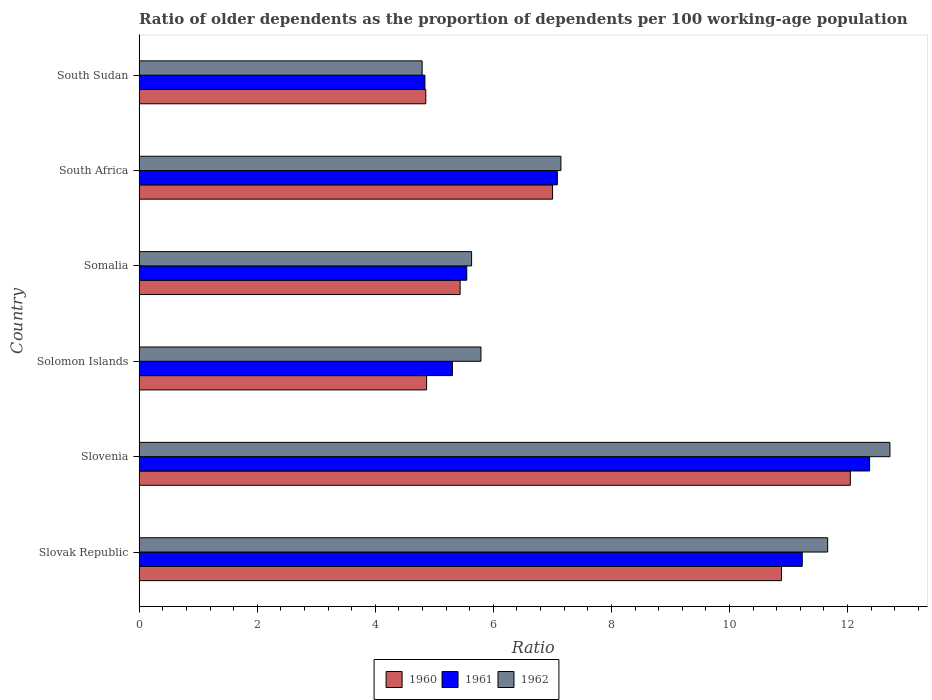How many different coloured bars are there?
Make the answer very short. 3. Are the number of bars per tick equal to the number of legend labels?
Offer a terse response. Yes. Are the number of bars on each tick of the Y-axis equal?
Make the answer very short. Yes. What is the label of the 4th group of bars from the top?
Keep it short and to the point. Solomon Islands. What is the age dependency ratio(old) in 1962 in Slovenia?
Your answer should be very brief. 12.72. Across all countries, what is the maximum age dependency ratio(old) in 1960?
Keep it short and to the point. 12.05. Across all countries, what is the minimum age dependency ratio(old) in 1961?
Your response must be concise. 4.84. In which country was the age dependency ratio(old) in 1961 maximum?
Give a very brief answer. Slovenia. In which country was the age dependency ratio(old) in 1962 minimum?
Ensure brevity in your answer.  South Sudan. What is the total age dependency ratio(old) in 1960 in the graph?
Make the answer very short. 45.1. What is the difference between the age dependency ratio(old) in 1961 in Slovenia and that in Somalia?
Make the answer very short. 6.82. What is the difference between the age dependency ratio(old) in 1960 in South Africa and the age dependency ratio(old) in 1962 in Somalia?
Your response must be concise. 1.37. What is the average age dependency ratio(old) in 1961 per country?
Provide a succinct answer. 7.73. What is the difference between the age dependency ratio(old) in 1962 and age dependency ratio(old) in 1961 in Solomon Islands?
Provide a succinct answer. 0.48. In how many countries, is the age dependency ratio(old) in 1960 greater than 10.4 ?
Offer a very short reply. 2. What is the ratio of the age dependency ratio(old) in 1962 in Slovenia to that in Somalia?
Make the answer very short. 2.26. Is the age dependency ratio(old) in 1962 in Slovenia less than that in Solomon Islands?
Provide a succinct answer. No. Is the difference between the age dependency ratio(old) in 1962 in Somalia and South Sudan greater than the difference between the age dependency ratio(old) in 1961 in Somalia and South Sudan?
Keep it short and to the point. Yes. What is the difference between the highest and the second highest age dependency ratio(old) in 1961?
Offer a terse response. 1.14. What is the difference between the highest and the lowest age dependency ratio(old) in 1962?
Your response must be concise. 7.92. What does the 3rd bar from the bottom in Slovak Republic represents?
Make the answer very short. 1962. Are all the bars in the graph horizontal?
Make the answer very short. Yes. What is the difference between two consecutive major ticks on the X-axis?
Make the answer very short. 2. Are the values on the major ticks of X-axis written in scientific E-notation?
Your answer should be very brief. No. How many legend labels are there?
Your answer should be compact. 3. What is the title of the graph?
Offer a very short reply. Ratio of older dependents as the proportion of dependents per 100 working-age population. What is the label or title of the X-axis?
Offer a very short reply. Ratio. What is the Ratio of 1960 in Slovak Republic?
Keep it short and to the point. 10.88. What is the Ratio of 1961 in Slovak Republic?
Keep it short and to the point. 11.23. What is the Ratio of 1962 in Slovak Republic?
Your answer should be very brief. 11.66. What is the Ratio in 1960 in Slovenia?
Offer a terse response. 12.05. What is the Ratio of 1961 in Slovenia?
Offer a very short reply. 12.37. What is the Ratio of 1962 in Slovenia?
Your answer should be very brief. 12.72. What is the Ratio in 1960 in Solomon Islands?
Your answer should be compact. 4.87. What is the Ratio of 1961 in Solomon Islands?
Give a very brief answer. 5.31. What is the Ratio of 1962 in Solomon Islands?
Your answer should be very brief. 5.79. What is the Ratio of 1960 in Somalia?
Give a very brief answer. 5.44. What is the Ratio in 1961 in Somalia?
Your answer should be very brief. 5.55. What is the Ratio in 1962 in Somalia?
Your answer should be compact. 5.63. What is the Ratio of 1960 in South Africa?
Ensure brevity in your answer.  7. What is the Ratio in 1961 in South Africa?
Make the answer very short. 7.08. What is the Ratio in 1962 in South Africa?
Offer a terse response. 7.14. What is the Ratio of 1960 in South Sudan?
Offer a very short reply. 4.86. What is the Ratio in 1961 in South Sudan?
Offer a very short reply. 4.84. What is the Ratio in 1962 in South Sudan?
Keep it short and to the point. 4.79. Across all countries, what is the maximum Ratio in 1960?
Provide a short and direct response. 12.05. Across all countries, what is the maximum Ratio of 1961?
Offer a very short reply. 12.37. Across all countries, what is the maximum Ratio in 1962?
Your answer should be compact. 12.72. Across all countries, what is the minimum Ratio of 1960?
Make the answer very short. 4.86. Across all countries, what is the minimum Ratio of 1961?
Ensure brevity in your answer.  4.84. Across all countries, what is the minimum Ratio in 1962?
Your response must be concise. 4.79. What is the total Ratio of 1960 in the graph?
Ensure brevity in your answer.  45.1. What is the total Ratio of 1961 in the graph?
Your answer should be very brief. 46.39. What is the total Ratio of 1962 in the graph?
Ensure brevity in your answer.  47.74. What is the difference between the Ratio in 1960 in Slovak Republic and that in Slovenia?
Provide a succinct answer. -1.17. What is the difference between the Ratio of 1961 in Slovak Republic and that in Slovenia?
Provide a succinct answer. -1.14. What is the difference between the Ratio of 1962 in Slovak Republic and that in Slovenia?
Give a very brief answer. -1.05. What is the difference between the Ratio in 1960 in Slovak Republic and that in Solomon Islands?
Keep it short and to the point. 6.01. What is the difference between the Ratio in 1961 in Slovak Republic and that in Solomon Islands?
Offer a very short reply. 5.93. What is the difference between the Ratio of 1962 in Slovak Republic and that in Solomon Islands?
Provide a succinct answer. 5.87. What is the difference between the Ratio in 1960 in Slovak Republic and that in Somalia?
Offer a terse response. 5.44. What is the difference between the Ratio in 1961 in Slovak Republic and that in Somalia?
Provide a succinct answer. 5.68. What is the difference between the Ratio in 1962 in Slovak Republic and that in Somalia?
Give a very brief answer. 6.03. What is the difference between the Ratio in 1960 in Slovak Republic and that in South Africa?
Your response must be concise. 3.88. What is the difference between the Ratio of 1961 in Slovak Republic and that in South Africa?
Keep it short and to the point. 4.15. What is the difference between the Ratio of 1962 in Slovak Republic and that in South Africa?
Keep it short and to the point. 4.52. What is the difference between the Ratio in 1960 in Slovak Republic and that in South Sudan?
Ensure brevity in your answer.  6.03. What is the difference between the Ratio of 1961 in Slovak Republic and that in South Sudan?
Give a very brief answer. 6.39. What is the difference between the Ratio of 1962 in Slovak Republic and that in South Sudan?
Your response must be concise. 6.87. What is the difference between the Ratio in 1960 in Slovenia and that in Solomon Islands?
Ensure brevity in your answer.  7.18. What is the difference between the Ratio in 1961 in Slovenia and that in Solomon Islands?
Offer a terse response. 7.07. What is the difference between the Ratio in 1962 in Slovenia and that in Solomon Islands?
Give a very brief answer. 6.93. What is the difference between the Ratio of 1960 in Slovenia and that in Somalia?
Keep it short and to the point. 6.61. What is the difference between the Ratio in 1961 in Slovenia and that in Somalia?
Give a very brief answer. 6.82. What is the difference between the Ratio in 1962 in Slovenia and that in Somalia?
Ensure brevity in your answer.  7.09. What is the difference between the Ratio in 1960 in Slovenia and that in South Africa?
Offer a terse response. 5.04. What is the difference between the Ratio in 1961 in Slovenia and that in South Africa?
Provide a succinct answer. 5.29. What is the difference between the Ratio of 1962 in Slovenia and that in South Africa?
Keep it short and to the point. 5.57. What is the difference between the Ratio in 1960 in Slovenia and that in South Sudan?
Provide a succinct answer. 7.19. What is the difference between the Ratio of 1961 in Slovenia and that in South Sudan?
Your answer should be very brief. 7.53. What is the difference between the Ratio in 1962 in Slovenia and that in South Sudan?
Your answer should be very brief. 7.92. What is the difference between the Ratio in 1960 in Solomon Islands and that in Somalia?
Your answer should be very brief. -0.57. What is the difference between the Ratio of 1961 in Solomon Islands and that in Somalia?
Your answer should be very brief. -0.24. What is the difference between the Ratio of 1962 in Solomon Islands and that in Somalia?
Your response must be concise. 0.16. What is the difference between the Ratio of 1960 in Solomon Islands and that in South Africa?
Provide a succinct answer. -2.13. What is the difference between the Ratio of 1961 in Solomon Islands and that in South Africa?
Your answer should be compact. -1.78. What is the difference between the Ratio in 1962 in Solomon Islands and that in South Africa?
Your answer should be compact. -1.35. What is the difference between the Ratio in 1960 in Solomon Islands and that in South Sudan?
Offer a very short reply. 0.01. What is the difference between the Ratio in 1961 in Solomon Islands and that in South Sudan?
Ensure brevity in your answer.  0.47. What is the difference between the Ratio in 1962 in Solomon Islands and that in South Sudan?
Offer a very short reply. 1. What is the difference between the Ratio in 1960 in Somalia and that in South Africa?
Your response must be concise. -1.57. What is the difference between the Ratio in 1961 in Somalia and that in South Africa?
Provide a succinct answer. -1.53. What is the difference between the Ratio of 1962 in Somalia and that in South Africa?
Give a very brief answer. -1.51. What is the difference between the Ratio of 1960 in Somalia and that in South Sudan?
Keep it short and to the point. 0.58. What is the difference between the Ratio in 1961 in Somalia and that in South Sudan?
Provide a succinct answer. 0.71. What is the difference between the Ratio of 1962 in Somalia and that in South Sudan?
Make the answer very short. 0.84. What is the difference between the Ratio in 1960 in South Africa and that in South Sudan?
Provide a short and direct response. 2.15. What is the difference between the Ratio of 1961 in South Africa and that in South Sudan?
Your response must be concise. 2.24. What is the difference between the Ratio of 1962 in South Africa and that in South Sudan?
Provide a succinct answer. 2.35. What is the difference between the Ratio in 1960 in Slovak Republic and the Ratio in 1961 in Slovenia?
Your response must be concise. -1.49. What is the difference between the Ratio in 1960 in Slovak Republic and the Ratio in 1962 in Slovenia?
Your response must be concise. -1.84. What is the difference between the Ratio in 1961 in Slovak Republic and the Ratio in 1962 in Slovenia?
Make the answer very short. -1.49. What is the difference between the Ratio in 1960 in Slovak Republic and the Ratio in 1961 in Solomon Islands?
Keep it short and to the point. 5.58. What is the difference between the Ratio in 1960 in Slovak Republic and the Ratio in 1962 in Solomon Islands?
Your response must be concise. 5.09. What is the difference between the Ratio of 1961 in Slovak Republic and the Ratio of 1962 in Solomon Islands?
Ensure brevity in your answer.  5.44. What is the difference between the Ratio of 1960 in Slovak Republic and the Ratio of 1961 in Somalia?
Offer a terse response. 5.33. What is the difference between the Ratio of 1960 in Slovak Republic and the Ratio of 1962 in Somalia?
Your answer should be compact. 5.25. What is the difference between the Ratio of 1961 in Slovak Republic and the Ratio of 1962 in Somalia?
Your answer should be compact. 5.6. What is the difference between the Ratio of 1960 in Slovak Republic and the Ratio of 1961 in South Africa?
Offer a terse response. 3.8. What is the difference between the Ratio of 1960 in Slovak Republic and the Ratio of 1962 in South Africa?
Provide a short and direct response. 3.74. What is the difference between the Ratio in 1961 in Slovak Republic and the Ratio in 1962 in South Africa?
Ensure brevity in your answer.  4.09. What is the difference between the Ratio in 1960 in Slovak Republic and the Ratio in 1961 in South Sudan?
Give a very brief answer. 6.04. What is the difference between the Ratio of 1960 in Slovak Republic and the Ratio of 1962 in South Sudan?
Keep it short and to the point. 6.09. What is the difference between the Ratio of 1961 in Slovak Republic and the Ratio of 1962 in South Sudan?
Your response must be concise. 6.44. What is the difference between the Ratio in 1960 in Slovenia and the Ratio in 1961 in Solomon Islands?
Provide a short and direct response. 6.74. What is the difference between the Ratio in 1960 in Slovenia and the Ratio in 1962 in Solomon Islands?
Make the answer very short. 6.26. What is the difference between the Ratio in 1961 in Slovenia and the Ratio in 1962 in Solomon Islands?
Provide a short and direct response. 6.58. What is the difference between the Ratio of 1960 in Slovenia and the Ratio of 1961 in Somalia?
Offer a terse response. 6.5. What is the difference between the Ratio in 1960 in Slovenia and the Ratio in 1962 in Somalia?
Your answer should be compact. 6.42. What is the difference between the Ratio of 1961 in Slovenia and the Ratio of 1962 in Somalia?
Offer a very short reply. 6.74. What is the difference between the Ratio in 1960 in Slovenia and the Ratio in 1961 in South Africa?
Make the answer very short. 4.96. What is the difference between the Ratio of 1960 in Slovenia and the Ratio of 1962 in South Africa?
Keep it short and to the point. 4.9. What is the difference between the Ratio in 1961 in Slovenia and the Ratio in 1962 in South Africa?
Offer a very short reply. 5.23. What is the difference between the Ratio of 1960 in Slovenia and the Ratio of 1961 in South Sudan?
Your response must be concise. 7.21. What is the difference between the Ratio of 1960 in Slovenia and the Ratio of 1962 in South Sudan?
Provide a succinct answer. 7.25. What is the difference between the Ratio in 1961 in Slovenia and the Ratio in 1962 in South Sudan?
Provide a succinct answer. 7.58. What is the difference between the Ratio of 1960 in Solomon Islands and the Ratio of 1961 in Somalia?
Your answer should be very brief. -0.68. What is the difference between the Ratio in 1960 in Solomon Islands and the Ratio in 1962 in Somalia?
Your answer should be very brief. -0.76. What is the difference between the Ratio of 1961 in Solomon Islands and the Ratio of 1962 in Somalia?
Make the answer very short. -0.33. What is the difference between the Ratio in 1960 in Solomon Islands and the Ratio in 1961 in South Africa?
Offer a terse response. -2.21. What is the difference between the Ratio of 1960 in Solomon Islands and the Ratio of 1962 in South Africa?
Offer a very short reply. -2.28. What is the difference between the Ratio of 1961 in Solomon Islands and the Ratio of 1962 in South Africa?
Provide a succinct answer. -1.84. What is the difference between the Ratio of 1960 in Solomon Islands and the Ratio of 1961 in South Sudan?
Ensure brevity in your answer.  0.03. What is the difference between the Ratio of 1960 in Solomon Islands and the Ratio of 1962 in South Sudan?
Offer a terse response. 0.08. What is the difference between the Ratio in 1961 in Solomon Islands and the Ratio in 1962 in South Sudan?
Keep it short and to the point. 0.51. What is the difference between the Ratio of 1960 in Somalia and the Ratio of 1961 in South Africa?
Keep it short and to the point. -1.65. What is the difference between the Ratio of 1960 in Somalia and the Ratio of 1962 in South Africa?
Offer a terse response. -1.71. What is the difference between the Ratio in 1961 in Somalia and the Ratio in 1962 in South Africa?
Provide a succinct answer. -1.6. What is the difference between the Ratio of 1960 in Somalia and the Ratio of 1961 in South Sudan?
Make the answer very short. 0.6. What is the difference between the Ratio of 1960 in Somalia and the Ratio of 1962 in South Sudan?
Provide a succinct answer. 0.64. What is the difference between the Ratio of 1961 in Somalia and the Ratio of 1962 in South Sudan?
Make the answer very short. 0.76. What is the difference between the Ratio of 1960 in South Africa and the Ratio of 1961 in South Sudan?
Your answer should be compact. 2.16. What is the difference between the Ratio of 1960 in South Africa and the Ratio of 1962 in South Sudan?
Make the answer very short. 2.21. What is the difference between the Ratio in 1961 in South Africa and the Ratio in 1962 in South Sudan?
Offer a terse response. 2.29. What is the average Ratio of 1960 per country?
Provide a short and direct response. 7.52. What is the average Ratio in 1961 per country?
Make the answer very short. 7.73. What is the average Ratio in 1962 per country?
Provide a short and direct response. 7.96. What is the difference between the Ratio in 1960 and Ratio in 1961 in Slovak Republic?
Make the answer very short. -0.35. What is the difference between the Ratio in 1960 and Ratio in 1962 in Slovak Republic?
Your answer should be compact. -0.78. What is the difference between the Ratio of 1961 and Ratio of 1962 in Slovak Republic?
Offer a terse response. -0.43. What is the difference between the Ratio in 1960 and Ratio in 1961 in Slovenia?
Offer a terse response. -0.33. What is the difference between the Ratio of 1960 and Ratio of 1962 in Slovenia?
Provide a short and direct response. -0.67. What is the difference between the Ratio in 1961 and Ratio in 1962 in Slovenia?
Your answer should be very brief. -0.34. What is the difference between the Ratio of 1960 and Ratio of 1961 in Solomon Islands?
Your answer should be compact. -0.44. What is the difference between the Ratio of 1960 and Ratio of 1962 in Solomon Islands?
Your answer should be compact. -0.92. What is the difference between the Ratio of 1961 and Ratio of 1962 in Solomon Islands?
Provide a short and direct response. -0.48. What is the difference between the Ratio of 1960 and Ratio of 1961 in Somalia?
Offer a very short reply. -0.11. What is the difference between the Ratio in 1960 and Ratio in 1962 in Somalia?
Keep it short and to the point. -0.19. What is the difference between the Ratio of 1961 and Ratio of 1962 in Somalia?
Provide a short and direct response. -0.08. What is the difference between the Ratio of 1960 and Ratio of 1961 in South Africa?
Your answer should be compact. -0.08. What is the difference between the Ratio in 1960 and Ratio in 1962 in South Africa?
Provide a short and direct response. -0.14. What is the difference between the Ratio of 1961 and Ratio of 1962 in South Africa?
Make the answer very short. -0.06. What is the difference between the Ratio in 1960 and Ratio in 1961 in South Sudan?
Your answer should be compact. 0.01. What is the difference between the Ratio in 1960 and Ratio in 1962 in South Sudan?
Your answer should be very brief. 0.06. What is the difference between the Ratio in 1961 and Ratio in 1962 in South Sudan?
Your answer should be compact. 0.05. What is the ratio of the Ratio in 1960 in Slovak Republic to that in Slovenia?
Your response must be concise. 0.9. What is the ratio of the Ratio of 1961 in Slovak Republic to that in Slovenia?
Give a very brief answer. 0.91. What is the ratio of the Ratio of 1962 in Slovak Republic to that in Slovenia?
Give a very brief answer. 0.92. What is the ratio of the Ratio of 1960 in Slovak Republic to that in Solomon Islands?
Offer a terse response. 2.23. What is the ratio of the Ratio of 1961 in Slovak Republic to that in Solomon Islands?
Your response must be concise. 2.12. What is the ratio of the Ratio of 1962 in Slovak Republic to that in Solomon Islands?
Provide a short and direct response. 2.01. What is the ratio of the Ratio in 1960 in Slovak Republic to that in Somalia?
Your response must be concise. 2. What is the ratio of the Ratio in 1961 in Slovak Republic to that in Somalia?
Your response must be concise. 2.02. What is the ratio of the Ratio of 1962 in Slovak Republic to that in Somalia?
Offer a very short reply. 2.07. What is the ratio of the Ratio in 1960 in Slovak Republic to that in South Africa?
Ensure brevity in your answer.  1.55. What is the ratio of the Ratio in 1961 in Slovak Republic to that in South Africa?
Your response must be concise. 1.59. What is the ratio of the Ratio of 1962 in Slovak Republic to that in South Africa?
Offer a terse response. 1.63. What is the ratio of the Ratio in 1960 in Slovak Republic to that in South Sudan?
Ensure brevity in your answer.  2.24. What is the ratio of the Ratio in 1961 in Slovak Republic to that in South Sudan?
Provide a succinct answer. 2.32. What is the ratio of the Ratio of 1962 in Slovak Republic to that in South Sudan?
Make the answer very short. 2.43. What is the ratio of the Ratio in 1960 in Slovenia to that in Solomon Islands?
Give a very brief answer. 2.47. What is the ratio of the Ratio in 1961 in Slovenia to that in Solomon Islands?
Keep it short and to the point. 2.33. What is the ratio of the Ratio of 1962 in Slovenia to that in Solomon Islands?
Provide a succinct answer. 2.2. What is the ratio of the Ratio of 1960 in Slovenia to that in Somalia?
Provide a succinct answer. 2.22. What is the ratio of the Ratio in 1961 in Slovenia to that in Somalia?
Your answer should be compact. 2.23. What is the ratio of the Ratio of 1962 in Slovenia to that in Somalia?
Make the answer very short. 2.26. What is the ratio of the Ratio of 1960 in Slovenia to that in South Africa?
Your answer should be very brief. 1.72. What is the ratio of the Ratio of 1961 in Slovenia to that in South Africa?
Provide a short and direct response. 1.75. What is the ratio of the Ratio of 1962 in Slovenia to that in South Africa?
Your answer should be very brief. 1.78. What is the ratio of the Ratio of 1960 in Slovenia to that in South Sudan?
Give a very brief answer. 2.48. What is the ratio of the Ratio in 1961 in Slovenia to that in South Sudan?
Provide a succinct answer. 2.56. What is the ratio of the Ratio of 1962 in Slovenia to that in South Sudan?
Provide a short and direct response. 2.65. What is the ratio of the Ratio in 1960 in Solomon Islands to that in Somalia?
Make the answer very short. 0.9. What is the ratio of the Ratio of 1961 in Solomon Islands to that in Somalia?
Provide a short and direct response. 0.96. What is the ratio of the Ratio in 1962 in Solomon Islands to that in Somalia?
Keep it short and to the point. 1.03. What is the ratio of the Ratio of 1960 in Solomon Islands to that in South Africa?
Offer a very short reply. 0.7. What is the ratio of the Ratio in 1961 in Solomon Islands to that in South Africa?
Your answer should be compact. 0.75. What is the ratio of the Ratio in 1962 in Solomon Islands to that in South Africa?
Your answer should be very brief. 0.81. What is the ratio of the Ratio of 1961 in Solomon Islands to that in South Sudan?
Your response must be concise. 1.1. What is the ratio of the Ratio of 1962 in Solomon Islands to that in South Sudan?
Give a very brief answer. 1.21. What is the ratio of the Ratio of 1960 in Somalia to that in South Africa?
Your answer should be compact. 0.78. What is the ratio of the Ratio in 1961 in Somalia to that in South Africa?
Ensure brevity in your answer.  0.78. What is the ratio of the Ratio in 1962 in Somalia to that in South Africa?
Offer a very short reply. 0.79. What is the ratio of the Ratio in 1960 in Somalia to that in South Sudan?
Your answer should be very brief. 1.12. What is the ratio of the Ratio in 1961 in Somalia to that in South Sudan?
Make the answer very short. 1.15. What is the ratio of the Ratio of 1962 in Somalia to that in South Sudan?
Your answer should be compact. 1.17. What is the ratio of the Ratio in 1960 in South Africa to that in South Sudan?
Offer a terse response. 1.44. What is the ratio of the Ratio of 1961 in South Africa to that in South Sudan?
Offer a terse response. 1.46. What is the ratio of the Ratio of 1962 in South Africa to that in South Sudan?
Your answer should be very brief. 1.49. What is the difference between the highest and the second highest Ratio of 1960?
Make the answer very short. 1.17. What is the difference between the highest and the second highest Ratio of 1961?
Your response must be concise. 1.14. What is the difference between the highest and the second highest Ratio of 1962?
Offer a very short reply. 1.05. What is the difference between the highest and the lowest Ratio in 1960?
Offer a very short reply. 7.19. What is the difference between the highest and the lowest Ratio of 1961?
Give a very brief answer. 7.53. What is the difference between the highest and the lowest Ratio in 1962?
Offer a very short reply. 7.92. 